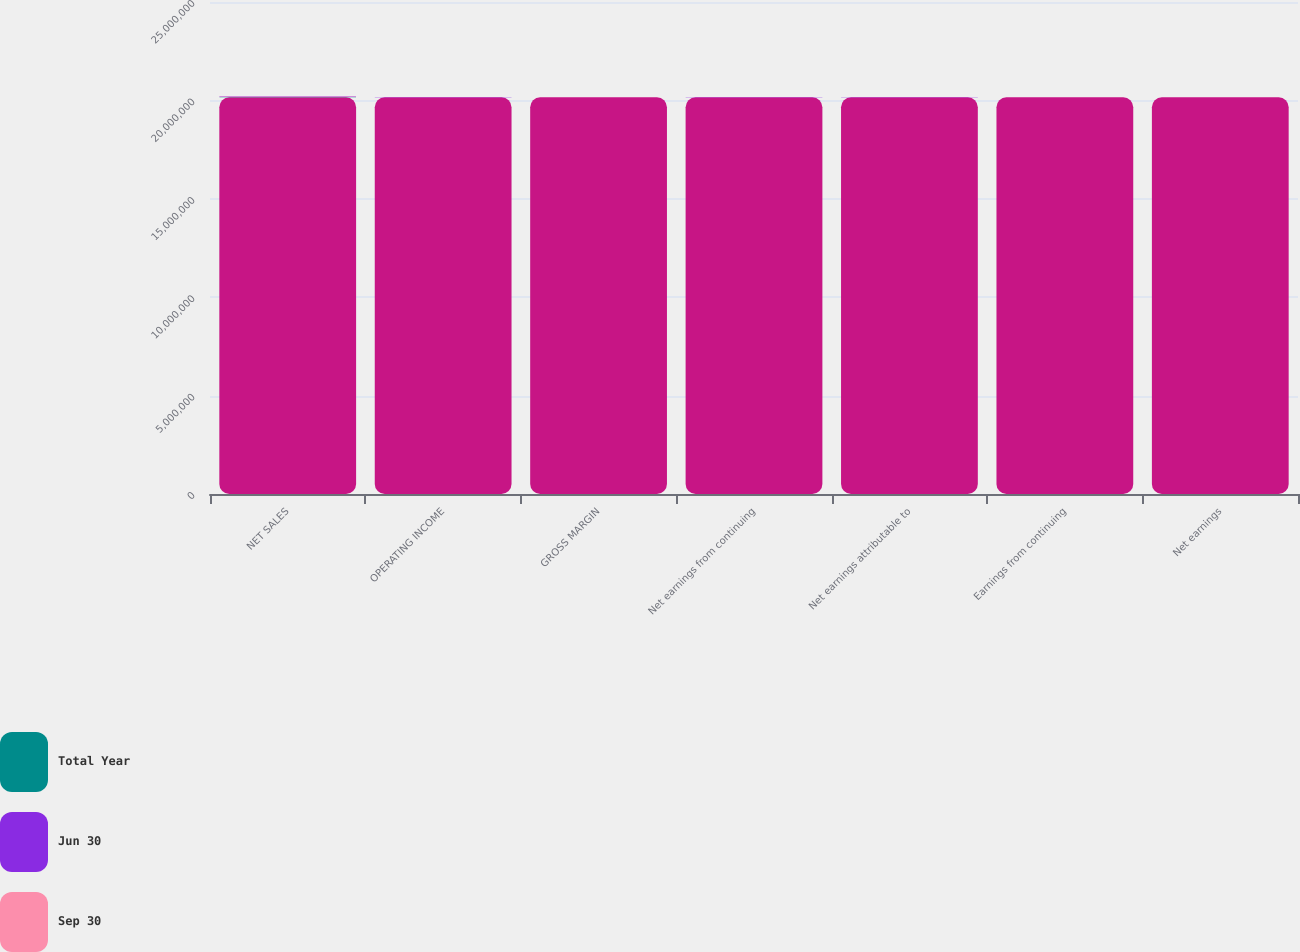Convert chart to OTSL. <chart><loc_0><loc_0><loc_500><loc_500><stacked_bar_chart><ecel><fcel>NET SALES<fcel>OPERATING INCOME<fcel>GROSS MARGIN<fcel>Net earnings from continuing<fcel>Net earnings attributable to<fcel>Earnings from continuing<fcel>Net earnings<nl><fcel>nan<fcel>2.0162e+07<fcel>2.0162e+07<fcel>2.0162e+07<fcel>2.0162e+07<fcel>2.0162e+07<fcel>2.0162e+07<fcel>2.0162e+07<nl><fcel>Total Year<fcel>16518<fcel>3771<fcel>51<fcel>2875<fcel>2714<fcel>1<fcel>0.96<nl><fcel>Jun 30<fcel>16856<fcel>3875<fcel>50.8<fcel>2561<fcel>7875<fcel>0.93<fcel>2.88<nl><fcel>Sep 30<fcel>15605<fcel>3360<fcel>49.8<fcel>2556<fcel>2522<fcel>0.93<fcel>0.93<nl></chart> 